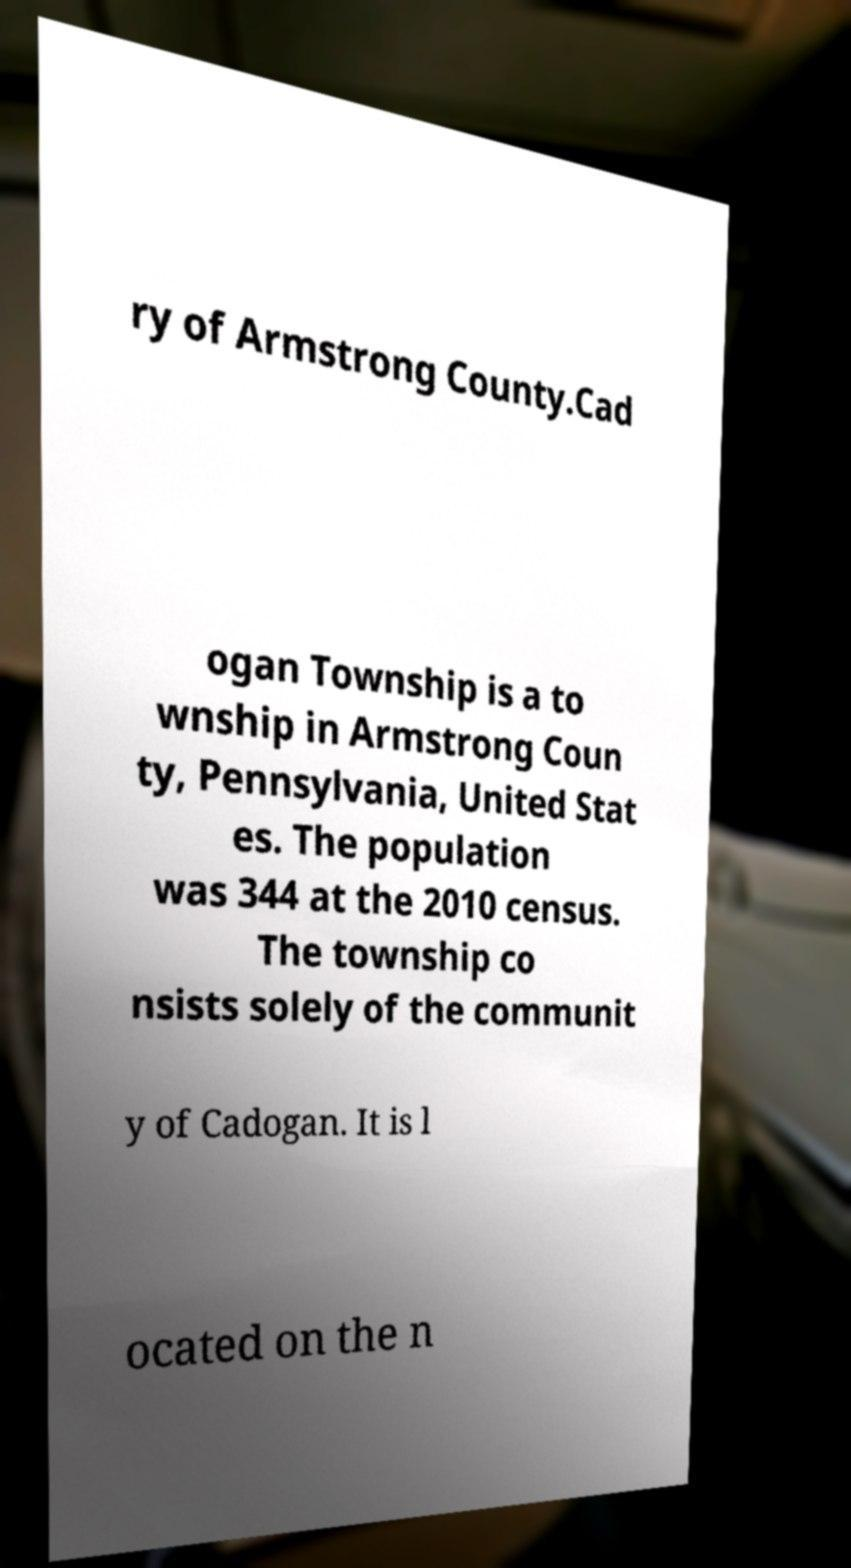I need the written content from this picture converted into text. Can you do that? ry of Armstrong County.Cad ogan Township is a to wnship in Armstrong Coun ty, Pennsylvania, United Stat es. The population was 344 at the 2010 census. The township co nsists solely of the communit y of Cadogan. It is l ocated on the n 